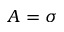<formula> <loc_0><loc_0><loc_500><loc_500>A = \sigma</formula> 